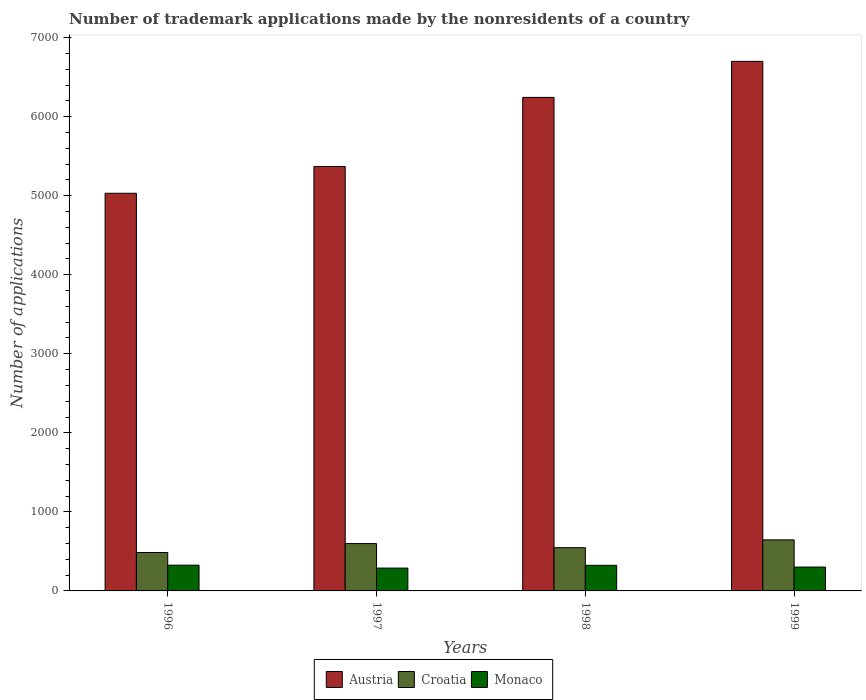How many different coloured bars are there?
Offer a very short reply. 3. How many groups of bars are there?
Make the answer very short. 4. Are the number of bars per tick equal to the number of legend labels?
Your response must be concise. Yes. Are the number of bars on each tick of the X-axis equal?
Make the answer very short. Yes. How many bars are there on the 4th tick from the left?
Give a very brief answer. 3. In how many cases, is the number of bars for a given year not equal to the number of legend labels?
Give a very brief answer. 0. What is the number of trademark applications made by the nonresidents in Croatia in 1996?
Keep it short and to the point. 486. Across all years, what is the maximum number of trademark applications made by the nonresidents in Monaco?
Ensure brevity in your answer.  326. Across all years, what is the minimum number of trademark applications made by the nonresidents in Monaco?
Your response must be concise. 289. In which year was the number of trademark applications made by the nonresidents in Croatia minimum?
Your response must be concise. 1996. What is the total number of trademark applications made by the nonresidents in Croatia in the graph?
Give a very brief answer. 2278. What is the difference between the number of trademark applications made by the nonresidents in Croatia in 1996 and that in 1999?
Provide a short and direct response. -160. What is the difference between the number of trademark applications made by the nonresidents in Croatia in 1996 and the number of trademark applications made by the nonresidents in Monaco in 1999?
Make the answer very short. 184. What is the average number of trademark applications made by the nonresidents in Monaco per year?
Ensure brevity in your answer.  310.25. In the year 1997, what is the difference between the number of trademark applications made by the nonresidents in Croatia and number of trademark applications made by the nonresidents in Monaco?
Provide a short and direct response. 310. What is the ratio of the number of trademark applications made by the nonresidents in Monaco in 1997 to that in 1999?
Offer a terse response. 0.96. Is the difference between the number of trademark applications made by the nonresidents in Croatia in 1997 and 1999 greater than the difference between the number of trademark applications made by the nonresidents in Monaco in 1997 and 1999?
Make the answer very short. No. What is the difference between the highest and the lowest number of trademark applications made by the nonresidents in Croatia?
Your answer should be compact. 160. Is the sum of the number of trademark applications made by the nonresidents in Austria in 1998 and 1999 greater than the maximum number of trademark applications made by the nonresidents in Croatia across all years?
Provide a succinct answer. Yes. What does the 3rd bar from the left in 1996 represents?
Ensure brevity in your answer.  Monaco. What does the 2nd bar from the right in 1996 represents?
Ensure brevity in your answer.  Croatia. Is it the case that in every year, the sum of the number of trademark applications made by the nonresidents in Croatia and number of trademark applications made by the nonresidents in Monaco is greater than the number of trademark applications made by the nonresidents in Austria?
Ensure brevity in your answer.  No. How many bars are there?
Your answer should be compact. 12. Are all the bars in the graph horizontal?
Your response must be concise. No. How many years are there in the graph?
Provide a short and direct response. 4. What is the difference between two consecutive major ticks on the Y-axis?
Ensure brevity in your answer.  1000. Are the values on the major ticks of Y-axis written in scientific E-notation?
Your answer should be very brief. No. How many legend labels are there?
Offer a terse response. 3. What is the title of the graph?
Your response must be concise. Number of trademark applications made by the nonresidents of a country. What is the label or title of the X-axis?
Offer a terse response. Years. What is the label or title of the Y-axis?
Make the answer very short. Number of applications. What is the Number of applications in Austria in 1996?
Keep it short and to the point. 5031. What is the Number of applications of Croatia in 1996?
Your answer should be very brief. 486. What is the Number of applications in Monaco in 1996?
Provide a succinct answer. 326. What is the Number of applications of Austria in 1997?
Your response must be concise. 5370. What is the Number of applications of Croatia in 1997?
Give a very brief answer. 599. What is the Number of applications in Monaco in 1997?
Offer a terse response. 289. What is the Number of applications of Austria in 1998?
Your response must be concise. 6244. What is the Number of applications of Croatia in 1998?
Provide a succinct answer. 547. What is the Number of applications in Monaco in 1998?
Make the answer very short. 324. What is the Number of applications in Austria in 1999?
Ensure brevity in your answer.  6700. What is the Number of applications of Croatia in 1999?
Your answer should be very brief. 646. What is the Number of applications of Monaco in 1999?
Provide a short and direct response. 302. Across all years, what is the maximum Number of applications of Austria?
Your response must be concise. 6700. Across all years, what is the maximum Number of applications in Croatia?
Keep it short and to the point. 646. Across all years, what is the maximum Number of applications in Monaco?
Make the answer very short. 326. Across all years, what is the minimum Number of applications in Austria?
Provide a short and direct response. 5031. Across all years, what is the minimum Number of applications of Croatia?
Make the answer very short. 486. Across all years, what is the minimum Number of applications of Monaco?
Provide a short and direct response. 289. What is the total Number of applications in Austria in the graph?
Ensure brevity in your answer.  2.33e+04. What is the total Number of applications in Croatia in the graph?
Give a very brief answer. 2278. What is the total Number of applications of Monaco in the graph?
Offer a terse response. 1241. What is the difference between the Number of applications of Austria in 1996 and that in 1997?
Offer a very short reply. -339. What is the difference between the Number of applications of Croatia in 1996 and that in 1997?
Provide a short and direct response. -113. What is the difference between the Number of applications in Monaco in 1996 and that in 1997?
Make the answer very short. 37. What is the difference between the Number of applications of Austria in 1996 and that in 1998?
Offer a terse response. -1213. What is the difference between the Number of applications in Croatia in 1996 and that in 1998?
Provide a short and direct response. -61. What is the difference between the Number of applications in Monaco in 1996 and that in 1998?
Offer a terse response. 2. What is the difference between the Number of applications in Austria in 1996 and that in 1999?
Give a very brief answer. -1669. What is the difference between the Number of applications in Croatia in 1996 and that in 1999?
Make the answer very short. -160. What is the difference between the Number of applications in Austria in 1997 and that in 1998?
Offer a terse response. -874. What is the difference between the Number of applications in Croatia in 1997 and that in 1998?
Your answer should be very brief. 52. What is the difference between the Number of applications in Monaco in 1997 and that in 1998?
Ensure brevity in your answer.  -35. What is the difference between the Number of applications of Austria in 1997 and that in 1999?
Make the answer very short. -1330. What is the difference between the Number of applications of Croatia in 1997 and that in 1999?
Your answer should be compact. -47. What is the difference between the Number of applications in Austria in 1998 and that in 1999?
Your answer should be very brief. -456. What is the difference between the Number of applications in Croatia in 1998 and that in 1999?
Provide a succinct answer. -99. What is the difference between the Number of applications of Austria in 1996 and the Number of applications of Croatia in 1997?
Offer a terse response. 4432. What is the difference between the Number of applications in Austria in 1996 and the Number of applications in Monaco in 1997?
Provide a short and direct response. 4742. What is the difference between the Number of applications of Croatia in 1996 and the Number of applications of Monaco in 1997?
Provide a short and direct response. 197. What is the difference between the Number of applications of Austria in 1996 and the Number of applications of Croatia in 1998?
Provide a succinct answer. 4484. What is the difference between the Number of applications in Austria in 1996 and the Number of applications in Monaco in 1998?
Keep it short and to the point. 4707. What is the difference between the Number of applications in Croatia in 1996 and the Number of applications in Monaco in 1998?
Make the answer very short. 162. What is the difference between the Number of applications in Austria in 1996 and the Number of applications in Croatia in 1999?
Offer a very short reply. 4385. What is the difference between the Number of applications of Austria in 1996 and the Number of applications of Monaco in 1999?
Provide a short and direct response. 4729. What is the difference between the Number of applications of Croatia in 1996 and the Number of applications of Monaco in 1999?
Keep it short and to the point. 184. What is the difference between the Number of applications in Austria in 1997 and the Number of applications in Croatia in 1998?
Keep it short and to the point. 4823. What is the difference between the Number of applications in Austria in 1997 and the Number of applications in Monaco in 1998?
Offer a very short reply. 5046. What is the difference between the Number of applications in Croatia in 1997 and the Number of applications in Monaco in 1998?
Keep it short and to the point. 275. What is the difference between the Number of applications of Austria in 1997 and the Number of applications of Croatia in 1999?
Provide a short and direct response. 4724. What is the difference between the Number of applications of Austria in 1997 and the Number of applications of Monaco in 1999?
Your response must be concise. 5068. What is the difference between the Number of applications in Croatia in 1997 and the Number of applications in Monaco in 1999?
Offer a very short reply. 297. What is the difference between the Number of applications in Austria in 1998 and the Number of applications in Croatia in 1999?
Offer a terse response. 5598. What is the difference between the Number of applications of Austria in 1998 and the Number of applications of Monaco in 1999?
Your response must be concise. 5942. What is the difference between the Number of applications of Croatia in 1998 and the Number of applications of Monaco in 1999?
Provide a short and direct response. 245. What is the average Number of applications of Austria per year?
Your response must be concise. 5836.25. What is the average Number of applications of Croatia per year?
Offer a very short reply. 569.5. What is the average Number of applications of Monaco per year?
Make the answer very short. 310.25. In the year 1996, what is the difference between the Number of applications of Austria and Number of applications of Croatia?
Give a very brief answer. 4545. In the year 1996, what is the difference between the Number of applications in Austria and Number of applications in Monaco?
Offer a very short reply. 4705. In the year 1996, what is the difference between the Number of applications of Croatia and Number of applications of Monaco?
Provide a succinct answer. 160. In the year 1997, what is the difference between the Number of applications in Austria and Number of applications in Croatia?
Your response must be concise. 4771. In the year 1997, what is the difference between the Number of applications in Austria and Number of applications in Monaco?
Offer a terse response. 5081. In the year 1997, what is the difference between the Number of applications in Croatia and Number of applications in Monaco?
Your answer should be compact. 310. In the year 1998, what is the difference between the Number of applications of Austria and Number of applications of Croatia?
Offer a very short reply. 5697. In the year 1998, what is the difference between the Number of applications in Austria and Number of applications in Monaco?
Offer a terse response. 5920. In the year 1998, what is the difference between the Number of applications in Croatia and Number of applications in Monaco?
Provide a short and direct response. 223. In the year 1999, what is the difference between the Number of applications of Austria and Number of applications of Croatia?
Your response must be concise. 6054. In the year 1999, what is the difference between the Number of applications of Austria and Number of applications of Monaco?
Provide a short and direct response. 6398. In the year 1999, what is the difference between the Number of applications in Croatia and Number of applications in Monaco?
Ensure brevity in your answer.  344. What is the ratio of the Number of applications in Austria in 1996 to that in 1997?
Provide a succinct answer. 0.94. What is the ratio of the Number of applications in Croatia in 1996 to that in 1997?
Give a very brief answer. 0.81. What is the ratio of the Number of applications in Monaco in 1996 to that in 1997?
Your answer should be compact. 1.13. What is the ratio of the Number of applications of Austria in 1996 to that in 1998?
Offer a terse response. 0.81. What is the ratio of the Number of applications in Croatia in 1996 to that in 1998?
Your answer should be very brief. 0.89. What is the ratio of the Number of applications of Monaco in 1996 to that in 1998?
Provide a short and direct response. 1.01. What is the ratio of the Number of applications in Austria in 1996 to that in 1999?
Give a very brief answer. 0.75. What is the ratio of the Number of applications of Croatia in 1996 to that in 1999?
Your answer should be compact. 0.75. What is the ratio of the Number of applications of Monaco in 1996 to that in 1999?
Offer a very short reply. 1.08. What is the ratio of the Number of applications of Austria in 1997 to that in 1998?
Your response must be concise. 0.86. What is the ratio of the Number of applications in Croatia in 1997 to that in 1998?
Make the answer very short. 1.1. What is the ratio of the Number of applications in Monaco in 1997 to that in 1998?
Your response must be concise. 0.89. What is the ratio of the Number of applications of Austria in 1997 to that in 1999?
Keep it short and to the point. 0.8. What is the ratio of the Number of applications in Croatia in 1997 to that in 1999?
Provide a short and direct response. 0.93. What is the ratio of the Number of applications of Austria in 1998 to that in 1999?
Give a very brief answer. 0.93. What is the ratio of the Number of applications in Croatia in 1998 to that in 1999?
Provide a short and direct response. 0.85. What is the ratio of the Number of applications of Monaco in 1998 to that in 1999?
Make the answer very short. 1.07. What is the difference between the highest and the second highest Number of applications in Austria?
Keep it short and to the point. 456. What is the difference between the highest and the second highest Number of applications in Croatia?
Offer a terse response. 47. What is the difference between the highest and the second highest Number of applications of Monaco?
Provide a short and direct response. 2. What is the difference between the highest and the lowest Number of applications in Austria?
Offer a terse response. 1669. What is the difference between the highest and the lowest Number of applications in Croatia?
Ensure brevity in your answer.  160. What is the difference between the highest and the lowest Number of applications in Monaco?
Your response must be concise. 37. 